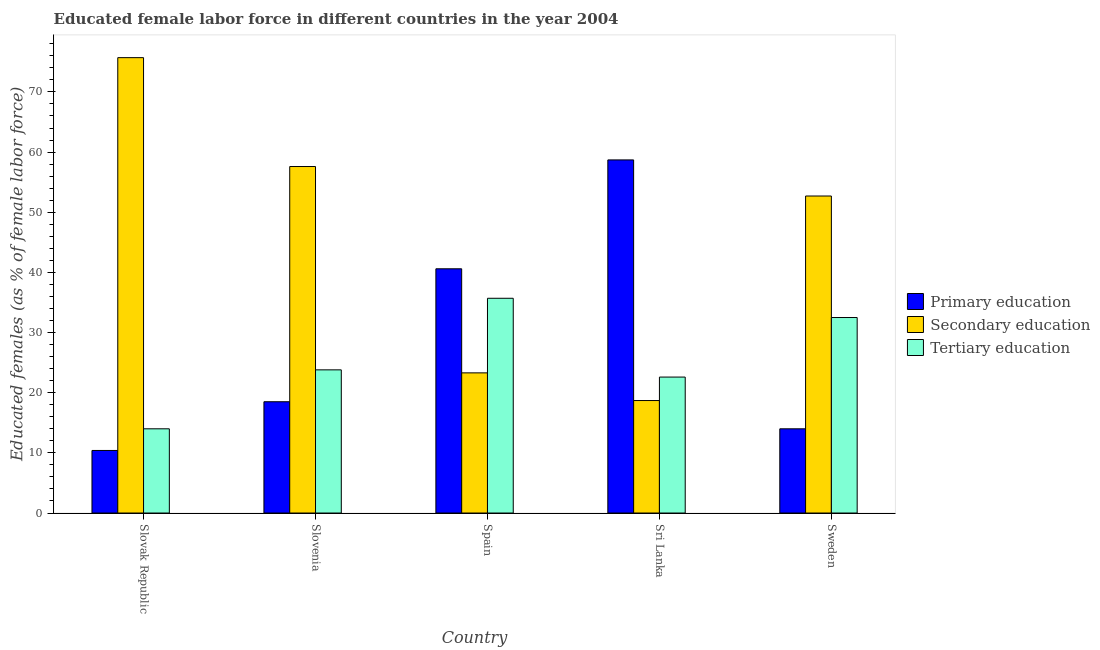How many different coloured bars are there?
Offer a very short reply. 3. How many groups of bars are there?
Offer a very short reply. 5. How many bars are there on the 3rd tick from the left?
Your response must be concise. 3. What is the percentage of female labor force who received tertiary education in Sweden?
Keep it short and to the point. 32.5. Across all countries, what is the maximum percentage of female labor force who received primary education?
Give a very brief answer. 58.7. Across all countries, what is the minimum percentage of female labor force who received tertiary education?
Provide a short and direct response. 14. In which country was the percentage of female labor force who received secondary education maximum?
Provide a succinct answer. Slovak Republic. In which country was the percentage of female labor force who received tertiary education minimum?
Provide a short and direct response. Slovak Republic. What is the total percentage of female labor force who received tertiary education in the graph?
Provide a short and direct response. 128.6. What is the difference between the percentage of female labor force who received tertiary education in Spain and that in Sri Lanka?
Keep it short and to the point. 13.1. What is the difference between the percentage of female labor force who received tertiary education in Slovak Republic and the percentage of female labor force who received secondary education in Sweden?
Offer a very short reply. -38.7. What is the average percentage of female labor force who received secondary education per country?
Provide a short and direct response. 45.6. What is the difference between the percentage of female labor force who received secondary education and percentage of female labor force who received primary education in Spain?
Provide a succinct answer. -17.3. In how many countries, is the percentage of female labor force who received tertiary education greater than 54 %?
Offer a very short reply. 0. What is the ratio of the percentage of female labor force who received secondary education in Sri Lanka to that in Sweden?
Offer a very short reply. 0.35. Is the percentage of female labor force who received tertiary education in Slovenia less than that in Spain?
Provide a short and direct response. Yes. What is the difference between the highest and the second highest percentage of female labor force who received primary education?
Give a very brief answer. 18.1. What is the difference between the highest and the lowest percentage of female labor force who received primary education?
Your answer should be very brief. 48.3. Is the sum of the percentage of female labor force who received secondary education in Sri Lanka and Sweden greater than the maximum percentage of female labor force who received tertiary education across all countries?
Make the answer very short. Yes. What does the 1st bar from the left in Sri Lanka represents?
Ensure brevity in your answer.  Primary education. What does the 1st bar from the right in Slovenia represents?
Keep it short and to the point. Tertiary education. Are all the bars in the graph horizontal?
Your response must be concise. No. Does the graph contain grids?
Give a very brief answer. No. How many legend labels are there?
Provide a short and direct response. 3. How are the legend labels stacked?
Your answer should be very brief. Vertical. What is the title of the graph?
Your answer should be very brief. Educated female labor force in different countries in the year 2004. What is the label or title of the X-axis?
Ensure brevity in your answer.  Country. What is the label or title of the Y-axis?
Your response must be concise. Educated females (as % of female labor force). What is the Educated females (as % of female labor force) of Primary education in Slovak Republic?
Provide a succinct answer. 10.4. What is the Educated females (as % of female labor force) of Secondary education in Slovak Republic?
Keep it short and to the point. 75.7. What is the Educated females (as % of female labor force) of Secondary education in Slovenia?
Offer a very short reply. 57.6. What is the Educated females (as % of female labor force) in Tertiary education in Slovenia?
Provide a short and direct response. 23.8. What is the Educated females (as % of female labor force) of Primary education in Spain?
Provide a short and direct response. 40.6. What is the Educated females (as % of female labor force) of Secondary education in Spain?
Your answer should be compact. 23.3. What is the Educated females (as % of female labor force) of Tertiary education in Spain?
Give a very brief answer. 35.7. What is the Educated females (as % of female labor force) of Primary education in Sri Lanka?
Provide a succinct answer. 58.7. What is the Educated females (as % of female labor force) in Secondary education in Sri Lanka?
Make the answer very short. 18.7. What is the Educated females (as % of female labor force) in Tertiary education in Sri Lanka?
Ensure brevity in your answer.  22.6. What is the Educated females (as % of female labor force) in Secondary education in Sweden?
Give a very brief answer. 52.7. What is the Educated females (as % of female labor force) in Tertiary education in Sweden?
Your answer should be very brief. 32.5. Across all countries, what is the maximum Educated females (as % of female labor force) of Primary education?
Your answer should be very brief. 58.7. Across all countries, what is the maximum Educated females (as % of female labor force) of Secondary education?
Keep it short and to the point. 75.7. Across all countries, what is the maximum Educated females (as % of female labor force) in Tertiary education?
Give a very brief answer. 35.7. Across all countries, what is the minimum Educated females (as % of female labor force) of Primary education?
Your response must be concise. 10.4. Across all countries, what is the minimum Educated females (as % of female labor force) in Secondary education?
Offer a very short reply. 18.7. Across all countries, what is the minimum Educated females (as % of female labor force) of Tertiary education?
Keep it short and to the point. 14. What is the total Educated females (as % of female labor force) in Primary education in the graph?
Make the answer very short. 142.2. What is the total Educated females (as % of female labor force) of Secondary education in the graph?
Provide a short and direct response. 228. What is the total Educated females (as % of female labor force) in Tertiary education in the graph?
Make the answer very short. 128.6. What is the difference between the Educated females (as % of female labor force) in Tertiary education in Slovak Republic and that in Slovenia?
Give a very brief answer. -9.8. What is the difference between the Educated females (as % of female labor force) in Primary education in Slovak Republic and that in Spain?
Your response must be concise. -30.2. What is the difference between the Educated females (as % of female labor force) in Secondary education in Slovak Republic and that in Spain?
Your answer should be very brief. 52.4. What is the difference between the Educated females (as % of female labor force) of Tertiary education in Slovak Republic and that in Spain?
Your answer should be very brief. -21.7. What is the difference between the Educated females (as % of female labor force) of Primary education in Slovak Republic and that in Sri Lanka?
Provide a succinct answer. -48.3. What is the difference between the Educated females (as % of female labor force) in Secondary education in Slovak Republic and that in Sri Lanka?
Provide a succinct answer. 57. What is the difference between the Educated females (as % of female labor force) of Primary education in Slovak Republic and that in Sweden?
Offer a very short reply. -3.6. What is the difference between the Educated females (as % of female labor force) in Tertiary education in Slovak Republic and that in Sweden?
Provide a short and direct response. -18.5. What is the difference between the Educated females (as % of female labor force) in Primary education in Slovenia and that in Spain?
Provide a succinct answer. -22.1. What is the difference between the Educated females (as % of female labor force) in Secondary education in Slovenia and that in Spain?
Your response must be concise. 34.3. What is the difference between the Educated females (as % of female labor force) of Tertiary education in Slovenia and that in Spain?
Keep it short and to the point. -11.9. What is the difference between the Educated females (as % of female labor force) in Primary education in Slovenia and that in Sri Lanka?
Offer a terse response. -40.2. What is the difference between the Educated females (as % of female labor force) of Secondary education in Slovenia and that in Sri Lanka?
Ensure brevity in your answer.  38.9. What is the difference between the Educated females (as % of female labor force) of Tertiary education in Slovenia and that in Sweden?
Provide a succinct answer. -8.7. What is the difference between the Educated females (as % of female labor force) in Primary education in Spain and that in Sri Lanka?
Ensure brevity in your answer.  -18.1. What is the difference between the Educated females (as % of female labor force) of Primary education in Spain and that in Sweden?
Keep it short and to the point. 26.6. What is the difference between the Educated females (as % of female labor force) of Secondary education in Spain and that in Sweden?
Provide a short and direct response. -29.4. What is the difference between the Educated females (as % of female labor force) in Primary education in Sri Lanka and that in Sweden?
Give a very brief answer. 44.7. What is the difference between the Educated females (as % of female labor force) in Secondary education in Sri Lanka and that in Sweden?
Provide a short and direct response. -34. What is the difference between the Educated females (as % of female labor force) of Tertiary education in Sri Lanka and that in Sweden?
Your response must be concise. -9.9. What is the difference between the Educated females (as % of female labor force) of Primary education in Slovak Republic and the Educated females (as % of female labor force) of Secondary education in Slovenia?
Your response must be concise. -47.2. What is the difference between the Educated females (as % of female labor force) of Primary education in Slovak Republic and the Educated females (as % of female labor force) of Tertiary education in Slovenia?
Provide a short and direct response. -13.4. What is the difference between the Educated females (as % of female labor force) of Secondary education in Slovak Republic and the Educated females (as % of female labor force) of Tertiary education in Slovenia?
Provide a succinct answer. 51.9. What is the difference between the Educated females (as % of female labor force) in Primary education in Slovak Republic and the Educated females (as % of female labor force) in Tertiary education in Spain?
Offer a very short reply. -25.3. What is the difference between the Educated females (as % of female labor force) of Secondary education in Slovak Republic and the Educated females (as % of female labor force) of Tertiary education in Spain?
Provide a short and direct response. 40. What is the difference between the Educated females (as % of female labor force) of Primary education in Slovak Republic and the Educated females (as % of female labor force) of Tertiary education in Sri Lanka?
Your response must be concise. -12.2. What is the difference between the Educated females (as % of female labor force) of Secondary education in Slovak Republic and the Educated females (as % of female labor force) of Tertiary education in Sri Lanka?
Ensure brevity in your answer.  53.1. What is the difference between the Educated females (as % of female labor force) of Primary education in Slovak Republic and the Educated females (as % of female labor force) of Secondary education in Sweden?
Your answer should be compact. -42.3. What is the difference between the Educated females (as % of female labor force) of Primary education in Slovak Republic and the Educated females (as % of female labor force) of Tertiary education in Sweden?
Offer a terse response. -22.1. What is the difference between the Educated females (as % of female labor force) of Secondary education in Slovak Republic and the Educated females (as % of female labor force) of Tertiary education in Sweden?
Your answer should be compact. 43.2. What is the difference between the Educated females (as % of female labor force) in Primary education in Slovenia and the Educated females (as % of female labor force) in Secondary education in Spain?
Ensure brevity in your answer.  -4.8. What is the difference between the Educated females (as % of female labor force) of Primary education in Slovenia and the Educated females (as % of female labor force) of Tertiary education in Spain?
Provide a short and direct response. -17.2. What is the difference between the Educated females (as % of female labor force) in Secondary education in Slovenia and the Educated females (as % of female labor force) in Tertiary education in Spain?
Keep it short and to the point. 21.9. What is the difference between the Educated females (as % of female labor force) in Secondary education in Slovenia and the Educated females (as % of female labor force) in Tertiary education in Sri Lanka?
Give a very brief answer. 35. What is the difference between the Educated females (as % of female labor force) in Primary education in Slovenia and the Educated females (as % of female labor force) in Secondary education in Sweden?
Give a very brief answer. -34.2. What is the difference between the Educated females (as % of female labor force) of Secondary education in Slovenia and the Educated females (as % of female labor force) of Tertiary education in Sweden?
Make the answer very short. 25.1. What is the difference between the Educated females (as % of female labor force) in Primary education in Spain and the Educated females (as % of female labor force) in Secondary education in Sri Lanka?
Your response must be concise. 21.9. What is the difference between the Educated females (as % of female labor force) of Primary education in Spain and the Educated females (as % of female labor force) of Tertiary education in Sri Lanka?
Ensure brevity in your answer.  18. What is the difference between the Educated females (as % of female labor force) in Primary education in Sri Lanka and the Educated females (as % of female labor force) in Tertiary education in Sweden?
Your answer should be compact. 26.2. What is the average Educated females (as % of female labor force) in Primary education per country?
Keep it short and to the point. 28.44. What is the average Educated females (as % of female labor force) of Secondary education per country?
Make the answer very short. 45.6. What is the average Educated females (as % of female labor force) of Tertiary education per country?
Keep it short and to the point. 25.72. What is the difference between the Educated females (as % of female labor force) in Primary education and Educated females (as % of female labor force) in Secondary education in Slovak Republic?
Offer a very short reply. -65.3. What is the difference between the Educated females (as % of female labor force) in Secondary education and Educated females (as % of female labor force) in Tertiary education in Slovak Republic?
Ensure brevity in your answer.  61.7. What is the difference between the Educated females (as % of female labor force) in Primary education and Educated females (as % of female labor force) in Secondary education in Slovenia?
Your response must be concise. -39.1. What is the difference between the Educated females (as % of female labor force) in Secondary education and Educated females (as % of female labor force) in Tertiary education in Slovenia?
Your response must be concise. 33.8. What is the difference between the Educated females (as % of female labor force) in Primary education and Educated females (as % of female labor force) in Secondary education in Spain?
Offer a terse response. 17.3. What is the difference between the Educated females (as % of female labor force) of Secondary education and Educated females (as % of female labor force) of Tertiary education in Spain?
Give a very brief answer. -12.4. What is the difference between the Educated females (as % of female labor force) in Primary education and Educated females (as % of female labor force) in Tertiary education in Sri Lanka?
Your response must be concise. 36.1. What is the difference between the Educated females (as % of female labor force) of Primary education and Educated females (as % of female labor force) of Secondary education in Sweden?
Offer a very short reply. -38.7. What is the difference between the Educated females (as % of female labor force) of Primary education and Educated females (as % of female labor force) of Tertiary education in Sweden?
Your answer should be compact. -18.5. What is the difference between the Educated females (as % of female labor force) in Secondary education and Educated females (as % of female labor force) in Tertiary education in Sweden?
Your answer should be compact. 20.2. What is the ratio of the Educated females (as % of female labor force) in Primary education in Slovak Republic to that in Slovenia?
Keep it short and to the point. 0.56. What is the ratio of the Educated females (as % of female labor force) in Secondary education in Slovak Republic to that in Slovenia?
Provide a short and direct response. 1.31. What is the ratio of the Educated females (as % of female labor force) in Tertiary education in Slovak Republic to that in Slovenia?
Provide a succinct answer. 0.59. What is the ratio of the Educated females (as % of female labor force) of Primary education in Slovak Republic to that in Spain?
Provide a succinct answer. 0.26. What is the ratio of the Educated females (as % of female labor force) in Secondary education in Slovak Republic to that in Spain?
Your response must be concise. 3.25. What is the ratio of the Educated females (as % of female labor force) of Tertiary education in Slovak Republic to that in Spain?
Make the answer very short. 0.39. What is the ratio of the Educated females (as % of female labor force) of Primary education in Slovak Republic to that in Sri Lanka?
Your answer should be compact. 0.18. What is the ratio of the Educated females (as % of female labor force) of Secondary education in Slovak Republic to that in Sri Lanka?
Offer a terse response. 4.05. What is the ratio of the Educated females (as % of female labor force) in Tertiary education in Slovak Republic to that in Sri Lanka?
Provide a succinct answer. 0.62. What is the ratio of the Educated females (as % of female labor force) of Primary education in Slovak Republic to that in Sweden?
Make the answer very short. 0.74. What is the ratio of the Educated females (as % of female labor force) in Secondary education in Slovak Republic to that in Sweden?
Keep it short and to the point. 1.44. What is the ratio of the Educated females (as % of female labor force) of Tertiary education in Slovak Republic to that in Sweden?
Make the answer very short. 0.43. What is the ratio of the Educated females (as % of female labor force) in Primary education in Slovenia to that in Spain?
Your response must be concise. 0.46. What is the ratio of the Educated females (as % of female labor force) of Secondary education in Slovenia to that in Spain?
Offer a terse response. 2.47. What is the ratio of the Educated females (as % of female labor force) of Tertiary education in Slovenia to that in Spain?
Provide a succinct answer. 0.67. What is the ratio of the Educated females (as % of female labor force) in Primary education in Slovenia to that in Sri Lanka?
Your answer should be compact. 0.32. What is the ratio of the Educated females (as % of female labor force) of Secondary education in Slovenia to that in Sri Lanka?
Ensure brevity in your answer.  3.08. What is the ratio of the Educated females (as % of female labor force) of Tertiary education in Slovenia to that in Sri Lanka?
Provide a succinct answer. 1.05. What is the ratio of the Educated females (as % of female labor force) of Primary education in Slovenia to that in Sweden?
Offer a terse response. 1.32. What is the ratio of the Educated females (as % of female labor force) in Secondary education in Slovenia to that in Sweden?
Provide a succinct answer. 1.09. What is the ratio of the Educated females (as % of female labor force) of Tertiary education in Slovenia to that in Sweden?
Keep it short and to the point. 0.73. What is the ratio of the Educated females (as % of female labor force) in Primary education in Spain to that in Sri Lanka?
Ensure brevity in your answer.  0.69. What is the ratio of the Educated females (as % of female labor force) of Secondary education in Spain to that in Sri Lanka?
Offer a terse response. 1.25. What is the ratio of the Educated females (as % of female labor force) of Tertiary education in Spain to that in Sri Lanka?
Keep it short and to the point. 1.58. What is the ratio of the Educated females (as % of female labor force) of Secondary education in Spain to that in Sweden?
Your answer should be very brief. 0.44. What is the ratio of the Educated females (as % of female labor force) in Tertiary education in Spain to that in Sweden?
Your answer should be very brief. 1.1. What is the ratio of the Educated females (as % of female labor force) of Primary education in Sri Lanka to that in Sweden?
Ensure brevity in your answer.  4.19. What is the ratio of the Educated females (as % of female labor force) of Secondary education in Sri Lanka to that in Sweden?
Your answer should be very brief. 0.35. What is the ratio of the Educated females (as % of female labor force) of Tertiary education in Sri Lanka to that in Sweden?
Ensure brevity in your answer.  0.7. What is the difference between the highest and the lowest Educated females (as % of female labor force) of Primary education?
Provide a succinct answer. 48.3. What is the difference between the highest and the lowest Educated females (as % of female labor force) in Tertiary education?
Ensure brevity in your answer.  21.7. 